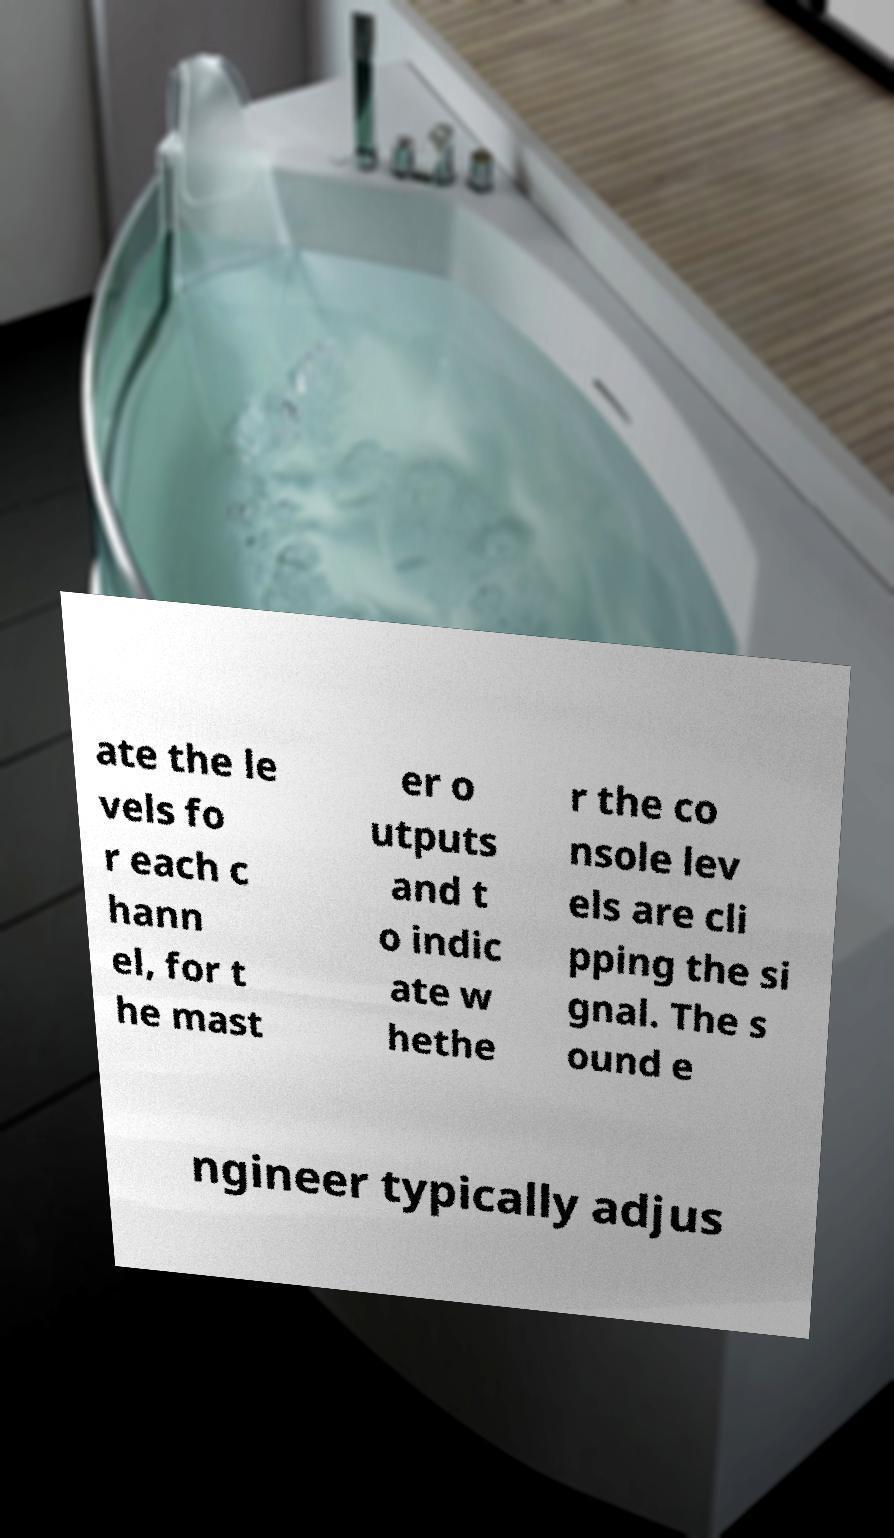For documentation purposes, I need the text within this image transcribed. Could you provide that? ate the le vels fo r each c hann el, for t he mast er o utputs and t o indic ate w hethe r the co nsole lev els are cli pping the si gnal. The s ound e ngineer typically adjus 